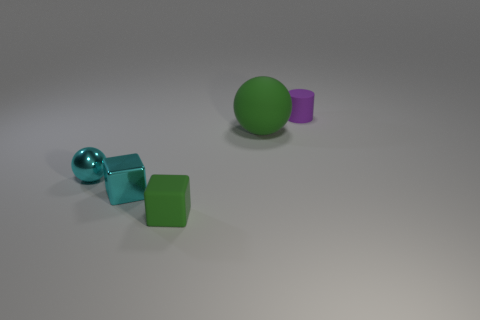Add 3 cyan metallic spheres. How many objects exist? 8 Subtract all cylinders. How many objects are left? 4 Add 2 cyan blocks. How many cyan blocks are left? 3 Add 2 rubber cylinders. How many rubber cylinders exist? 3 Subtract 0 yellow cylinders. How many objects are left? 5 Subtract all tiny blue metal cylinders. Subtract all cyan metallic cubes. How many objects are left? 4 